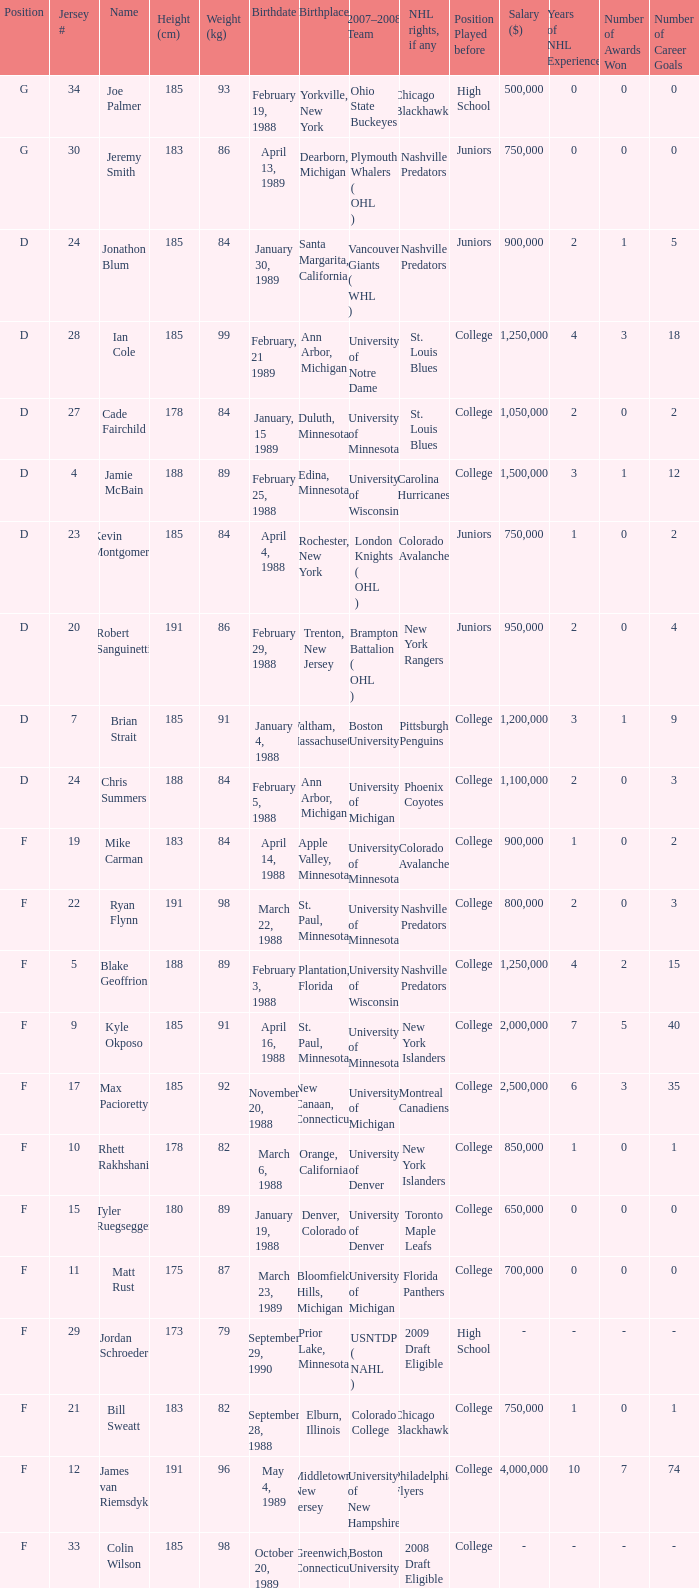Which Height (cm) has a Birthplace of new canaan, connecticut? 1.0. 